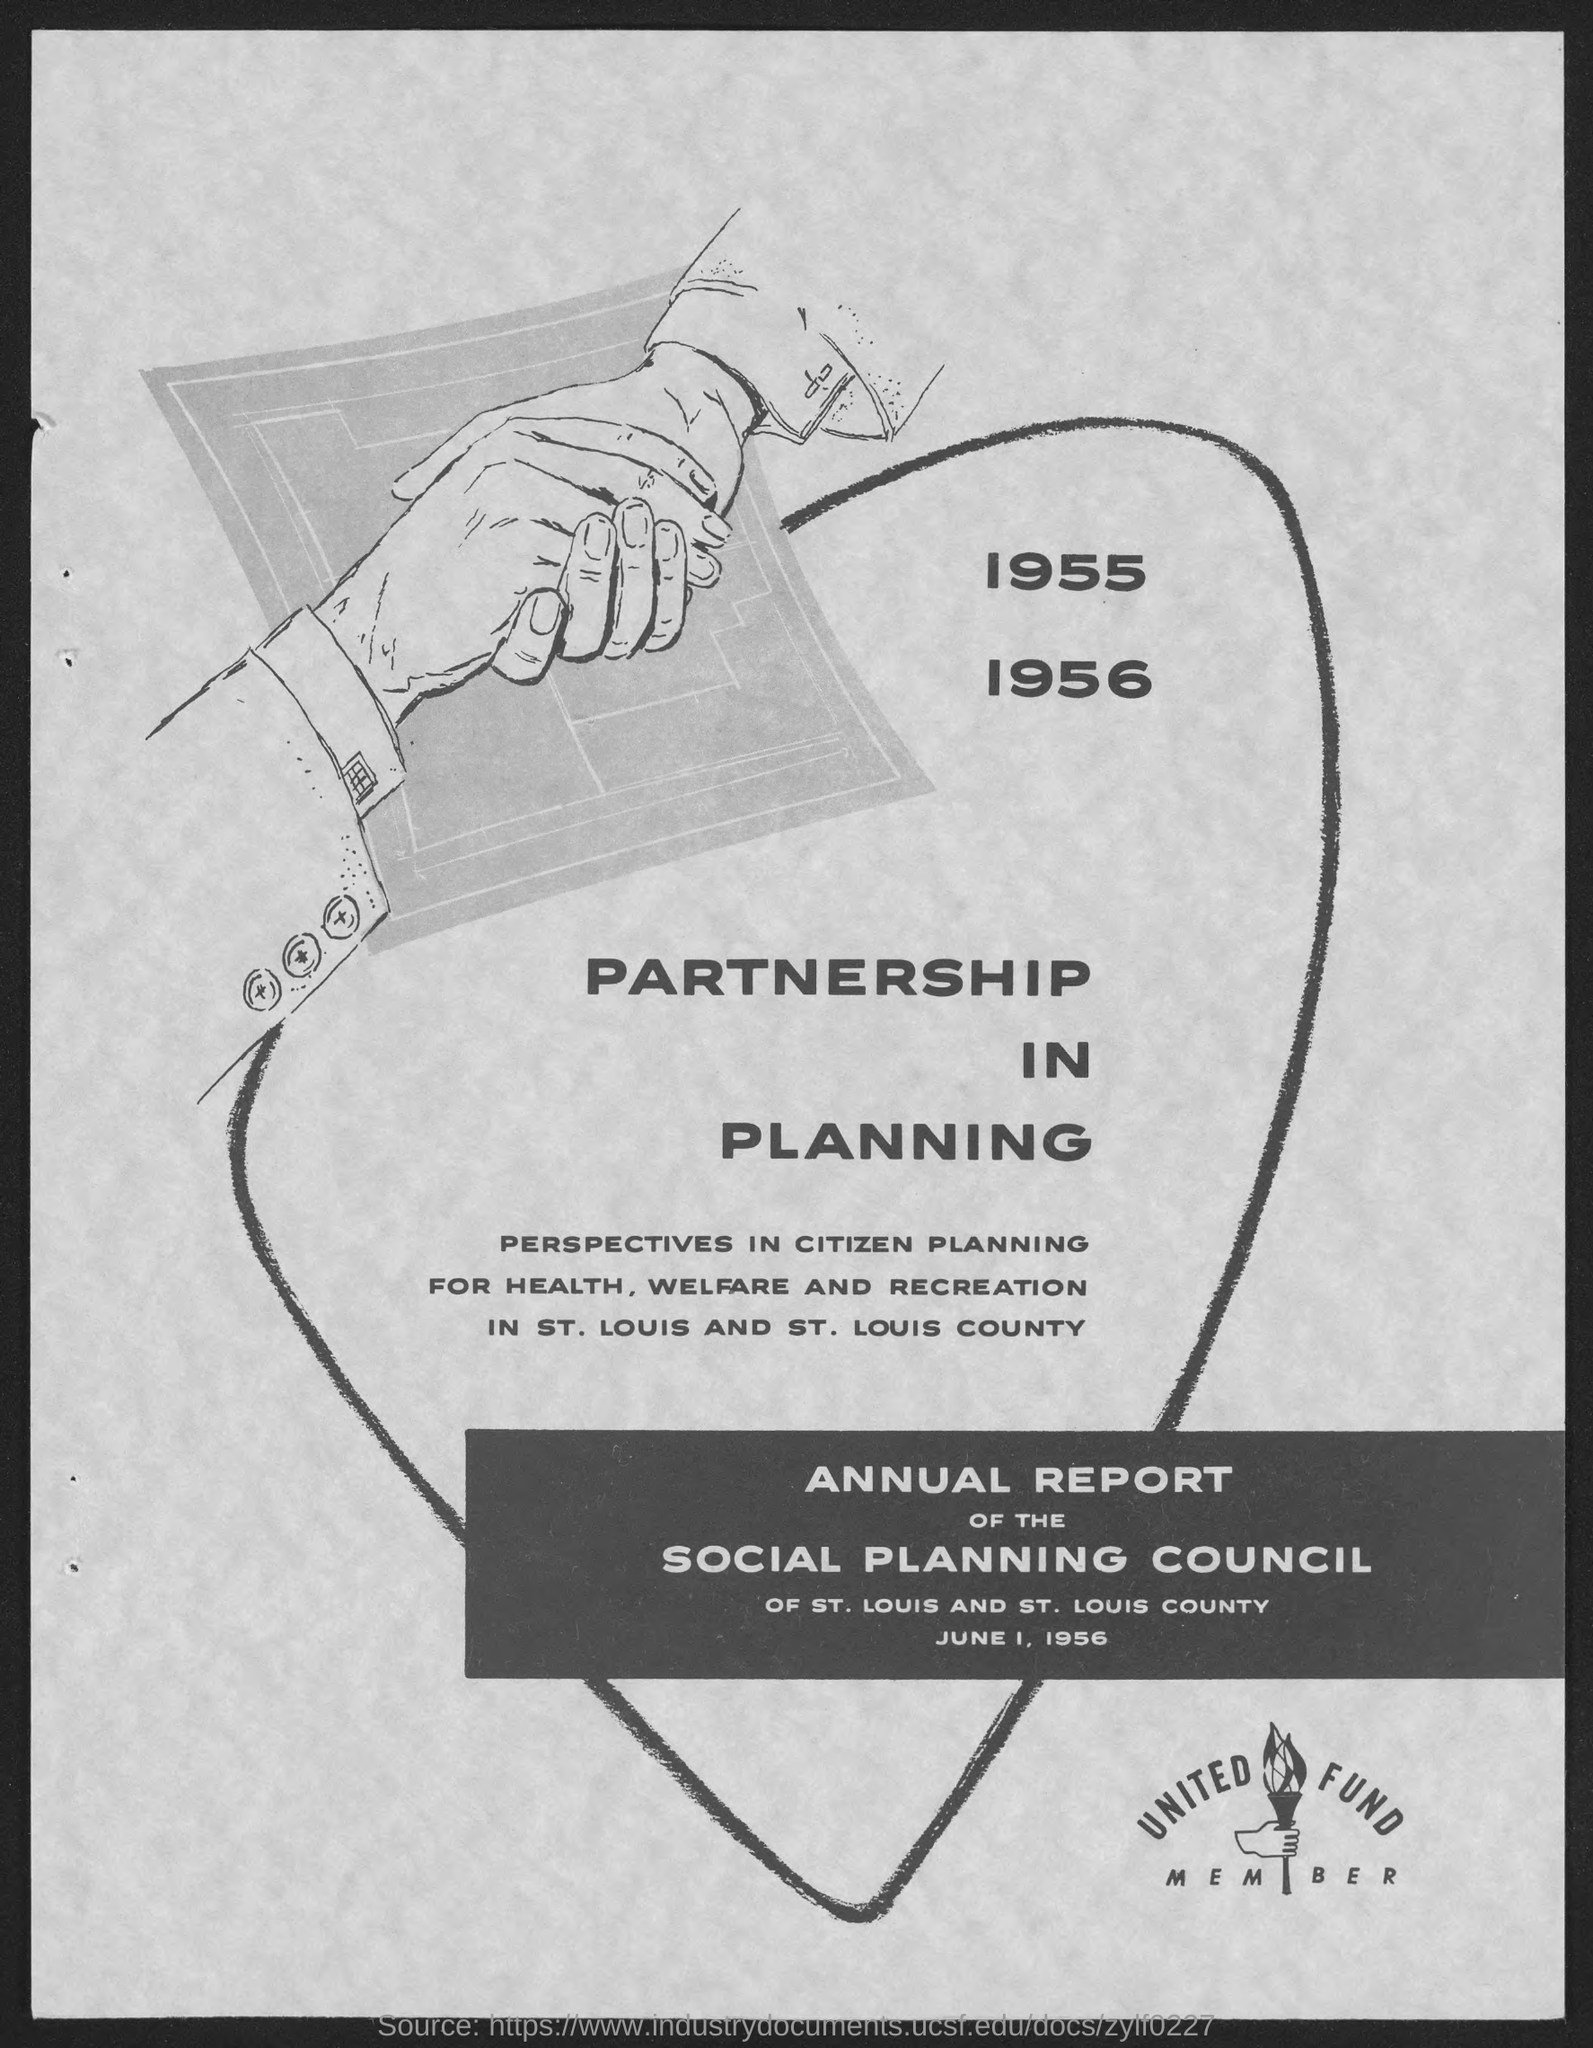List a handful of essential elements in this visual. The date mentioned in the given page is June 1, 1956. The given page mentions a report that consists of information about the annual report of the Social Planning Council. The heading mentioned in the given page is 'Partnership in Planning'. 